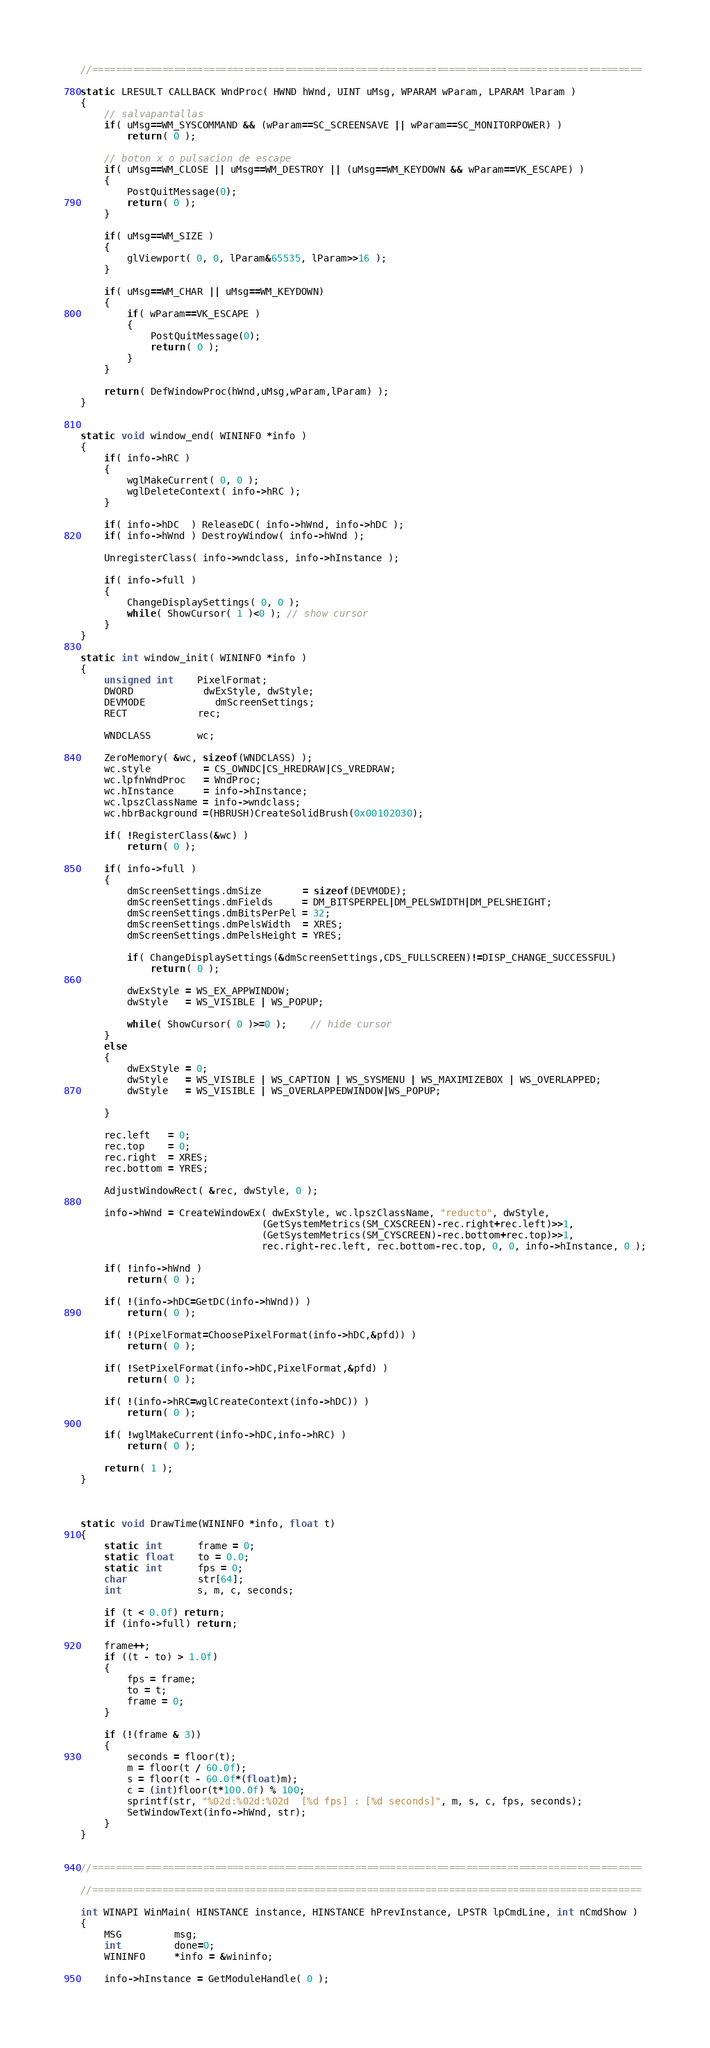Convert code to text. <code><loc_0><loc_0><loc_500><loc_500><_C++_>//==============================================================================================

static LRESULT CALLBACK WndProc( HWND hWnd, UINT uMsg, WPARAM wParam, LPARAM lParam )
{
	// salvapantallas
	if( uMsg==WM_SYSCOMMAND && (wParam==SC_SCREENSAVE || wParam==SC_MONITORPOWER) )
		return( 0 );

	// boton x o pulsacion de escape
	if( uMsg==WM_CLOSE || uMsg==WM_DESTROY || (uMsg==WM_KEYDOWN && wParam==VK_ESCAPE) )
	{
		PostQuitMessage(0);
        return( 0 );
	}

    if( uMsg==WM_SIZE )
    {
        glViewport( 0, 0, lParam&65535, lParam>>16 );
    }

    if( uMsg==WM_CHAR || uMsg==WM_KEYDOWN)
    {
        if( wParam==VK_ESCAPE )
        {
            PostQuitMessage(0);
            return( 0 );
        }
    }

    return( DefWindowProc(hWnd,uMsg,wParam,lParam) );
}


static void window_end( WININFO *info )
{
    if( info->hRC )
    {
        wglMakeCurrent( 0, 0 );
        wglDeleteContext( info->hRC );
    }

    if( info->hDC  ) ReleaseDC( info->hWnd, info->hDC );
    if( info->hWnd ) DestroyWindow( info->hWnd );

    UnregisterClass( info->wndclass, info->hInstance );

    if( info->full )
    {
        ChangeDisplaySettings( 0, 0 );
		while( ShowCursor( 1 )<0 ); // show cursor
    }
}

static int window_init( WININFO *info )
{
	unsigned int	PixelFormat;
    DWORD			dwExStyle, dwStyle;
    DEVMODE			dmScreenSettings;
    RECT			rec;

    WNDCLASS		wc;

    ZeroMemory( &wc, sizeof(WNDCLASS) );
    wc.style         = CS_OWNDC|CS_HREDRAW|CS_VREDRAW;
    wc.lpfnWndProc   = WndProc;
    wc.hInstance     = info->hInstance;
    wc.lpszClassName = info->wndclass;
    wc.hbrBackground =(HBRUSH)CreateSolidBrush(0x00102030);
	
    if( !RegisterClass(&wc) )
        return( 0 );

    if( info->full )
    {
        dmScreenSettings.dmSize       = sizeof(DEVMODE);
        dmScreenSettings.dmFields     = DM_BITSPERPEL|DM_PELSWIDTH|DM_PELSHEIGHT;
        dmScreenSettings.dmBitsPerPel = 32;
        dmScreenSettings.dmPelsWidth  = XRES;
        dmScreenSettings.dmPelsHeight = YRES;

        if( ChangeDisplaySettings(&dmScreenSettings,CDS_FULLSCREEN)!=DISP_CHANGE_SUCCESSFUL)
            return( 0 );

        dwExStyle = WS_EX_APPWINDOW;
        dwStyle   = WS_VISIBLE | WS_POPUP;

		while( ShowCursor( 0 )>=0 );	// hide cursor
    }
    else
    {
        dwExStyle = 0;
        dwStyle   = WS_VISIBLE | WS_CAPTION | WS_SYSMENU | WS_MAXIMIZEBOX | WS_OVERLAPPED;
		dwStyle   = WS_VISIBLE | WS_OVERLAPPEDWINDOW|WS_POPUP;

    }

    rec.left   = 0;
    rec.top    = 0;
    rec.right  = XRES;
    rec.bottom = YRES;

    AdjustWindowRect( &rec, dwStyle, 0 );

    info->hWnd = CreateWindowEx( dwExStyle, wc.lpszClassName, "reducto", dwStyle,
                               (GetSystemMetrics(SM_CXSCREEN)-rec.right+rec.left)>>1,
                               (GetSystemMetrics(SM_CYSCREEN)-rec.bottom+rec.top)>>1,
                               rec.right-rec.left, rec.bottom-rec.top, 0, 0, info->hInstance, 0 );

    if( !info->hWnd )
        return( 0 );

    if( !(info->hDC=GetDC(info->hWnd)) )
        return( 0 );

    if( !(PixelFormat=ChoosePixelFormat(info->hDC,&pfd)) )
        return( 0 );

    if( !SetPixelFormat(info->hDC,PixelFormat,&pfd) )
        return( 0 );

    if( !(info->hRC=wglCreateContext(info->hDC)) )
        return( 0 );

    if( !wglMakeCurrent(info->hDC,info->hRC) )
        return( 0 );

    return( 1 );
}



static void DrawTime(WININFO *info, float t)
{
	static int      frame = 0;
	static float    to = 0.0;
	static int      fps = 0;
	char            str[64];
	int             s, m, c, seconds;

	if (t < 0.0f) return;
	if (info->full) return;

	frame++;
	if ((t - to) > 1.0f)
	{
		fps = frame;
		to = t;
		frame = 0;
	}

	if (!(frame & 3))
	{
		seconds = floor(t);
		m = floor(t / 60.0f);
		s = floor(t - 60.0f*(float)m);
		c = (int)floor(t*100.0f) % 100;
		sprintf(str, "%02d:%02d:%02d  [%d fps] : [%d seconds]", m, s, c, fps, seconds);
		SetWindowText(info->hWnd, str);
	}
}


//==============================================================================================

//==============================================================================================

int WINAPI WinMain( HINSTANCE instance, HINSTANCE hPrevInstance, LPSTR lpCmdLine, int nCmdShow )
{
    MSG         msg;
    int         done=0;
    WININFO     *info = &wininfo;

    info->hInstance = GetModuleHandle( 0 );
</code> 